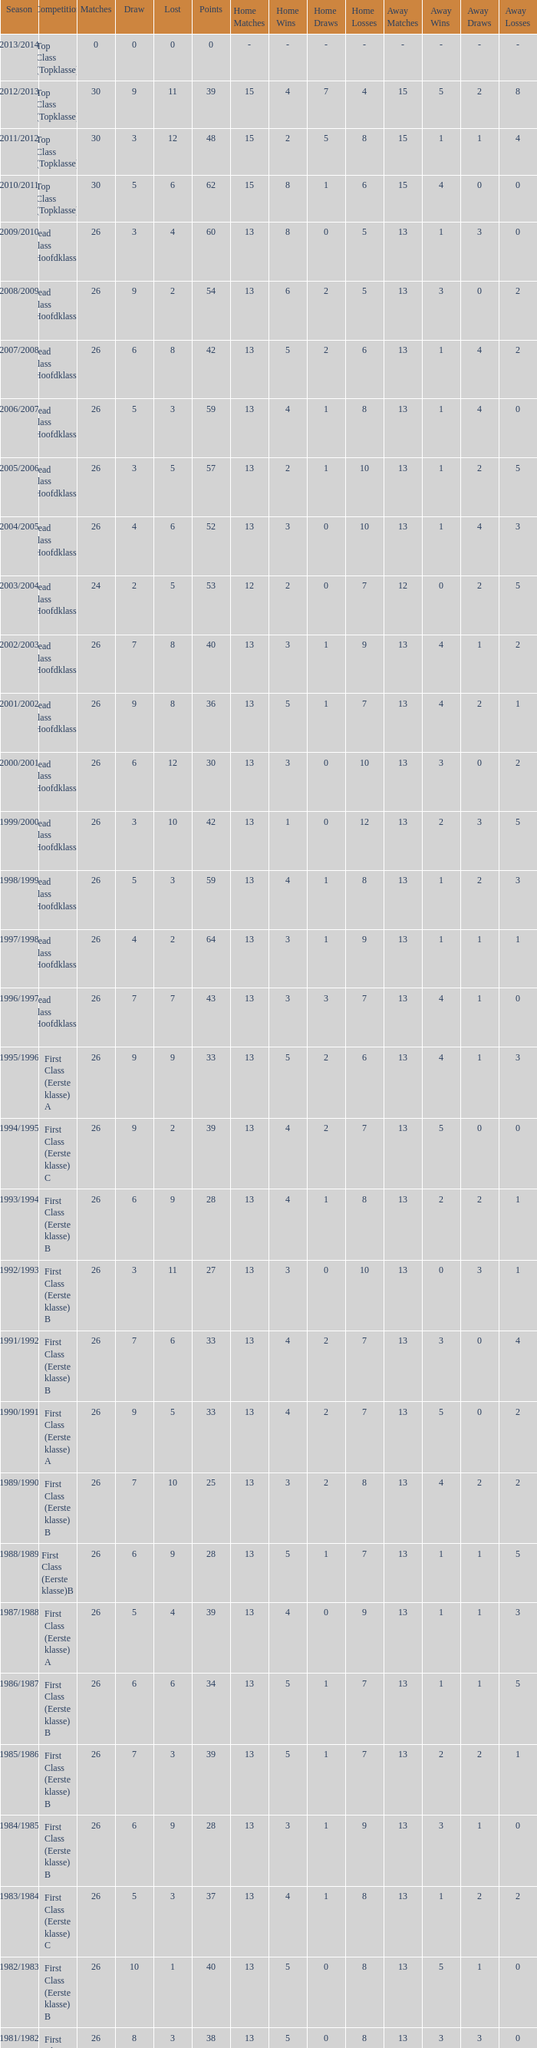What is the total number of matches with a loss less than 5 in the 2008/2009 season and has a draw larger than 9? 0.0. 